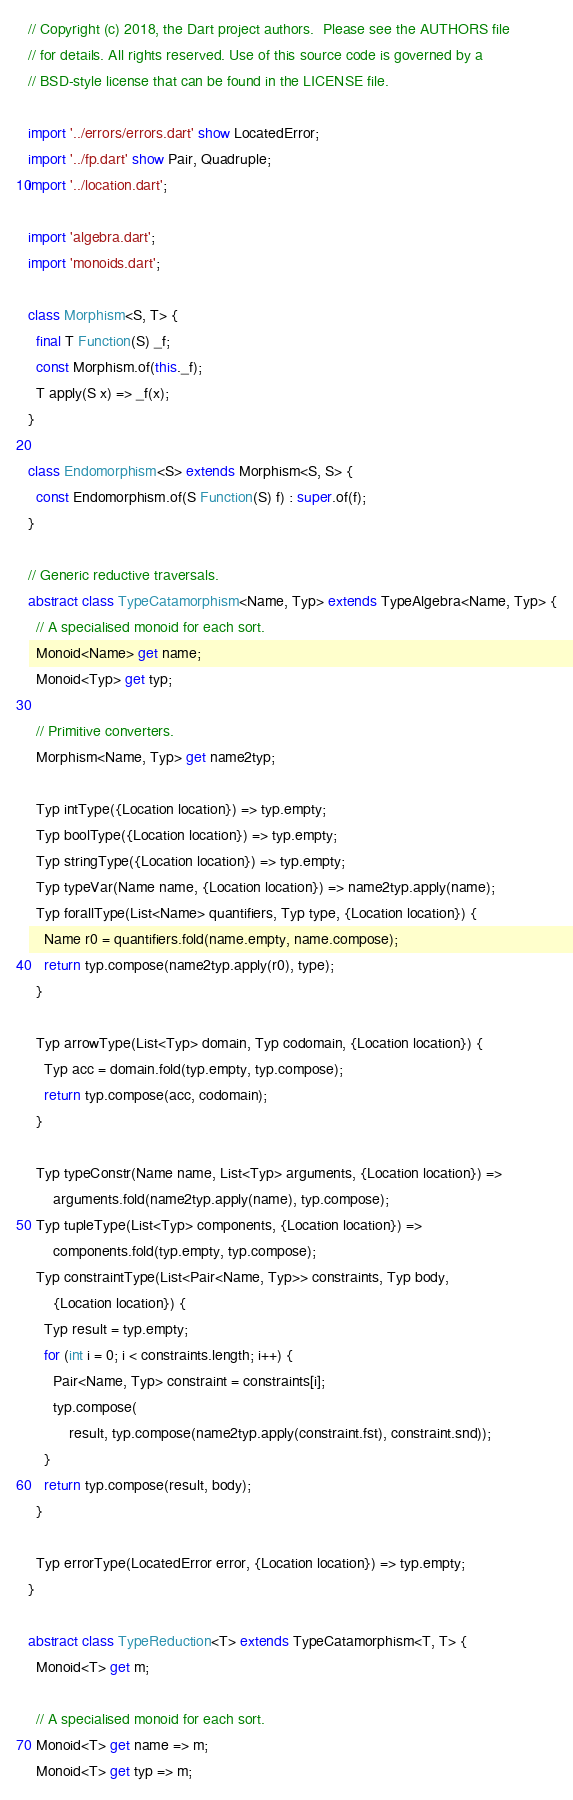Convert code to text. <code><loc_0><loc_0><loc_500><loc_500><_Dart_>// Copyright (c) 2018, the Dart project authors.  Please see the AUTHORS file
// for details. All rights reserved. Use of this source code is governed by a
// BSD-style license that can be found in the LICENSE file.

import '../errors/errors.dart' show LocatedError;
import '../fp.dart' show Pair, Quadruple;
import '../location.dart';

import 'algebra.dart';
import 'monoids.dart';

class Morphism<S, T> {
  final T Function(S) _f;
  const Morphism.of(this._f);
  T apply(S x) => _f(x);
}

class Endomorphism<S> extends Morphism<S, S> {
  const Endomorphism.of(S Function(S) f) : super.of(f);
}

// Generic reductive traversals.
abstract class TypeCatamorphism<Name, Typ> extends TypeAlgebra<Name, Typ> {
  // A specialised monoid for each sort.
  Monoid<Name> get name;
  Monoid<Typ> get typ;

  // Primitive converters.
  Morphism<Name, Typ> get name2typ;

  Typ intType({Location location}) => typ.empty;
  Typ boolType({Location location}) => typ.empty;
  Typ stringType({Location location}) => typ.empty;
  Typ typeVar(Name name, {Location location}) => name2typ.apply(name);
  Typ forallType(List<Name> quantifiers, Typ type, {Location location}) {
    Name r0 = quantifiers.fold(name.empty, name.compose);
    return typ.compose(name2typ.apply(r0), type);
  }

  Typ arrowType(List<Typ> domain, Typ codomain, {Location location}) {
    Typ acc = domain.fold(typ.empty, typ.compose);
    return typ.compose(acc, codomain);
  }

  Typ typeConstr(Name name, List<Typ> arguments, {Location location}) =>
      arguments.fold(name2typ.apply(name), typ.compose);
  Typ tupleType(List<Typ> components, {Location location}) =>
      components.fold(typ.empty, typ.compose);
  Typ constraintType(List<Pair<Name, Typ>> constraints, Typ body,
      {Location location}) {
    Typ result = typ.empty;
    for (int i = 0; i < constraints.length; i++) {
      Pair<Name, Typ> constraint = constraints[i];
      typ.compose(
          result, typ.compose(name2typ.apply(constraint.fst), constraint.snd));
    }
    return typ.compose(result, body);
  }

  Typ errorType(LocatedError error, {Location location}) => typ.empty;
}

abstract class TypeReduction<T> extends TypeCatamorphism<T, T> {
  Monoid<T> get m;

  // A specialised monoid for each sort.
  Monoid<T> get name => m;
  Monoid<T> get typ => m;
</code> 